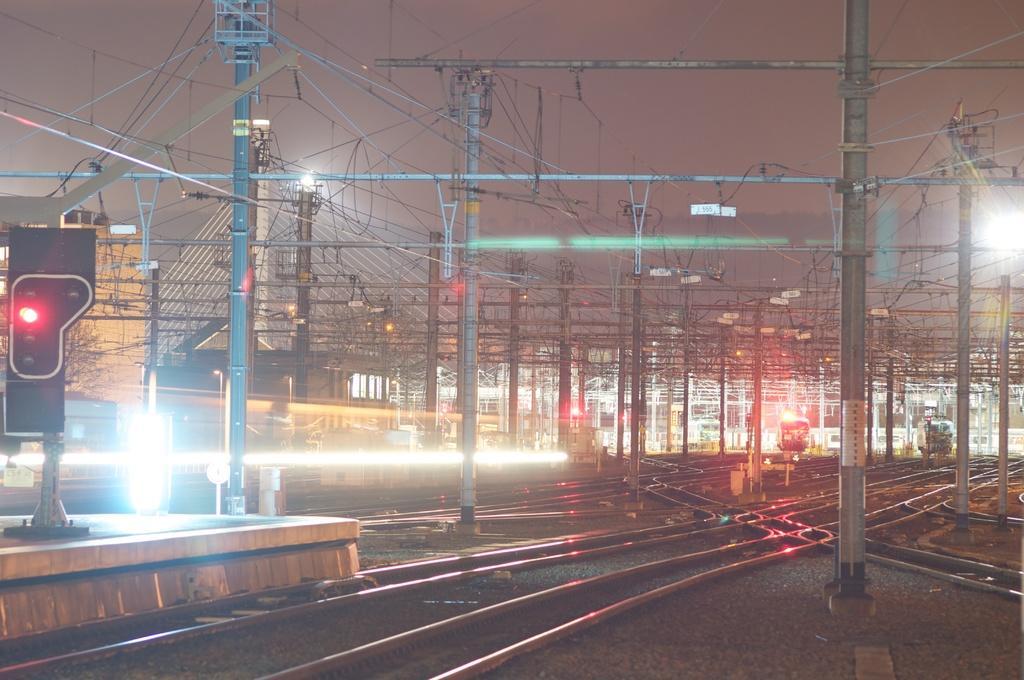In one or two sentences, can you explain what this image depicts? The image is taken near a railway station. In the foreground of the picture there are railway tracks, poles, cables, signal lights, stones and lights. In the background there are poles, cables, trains, building and lights. At the top it is sky. 